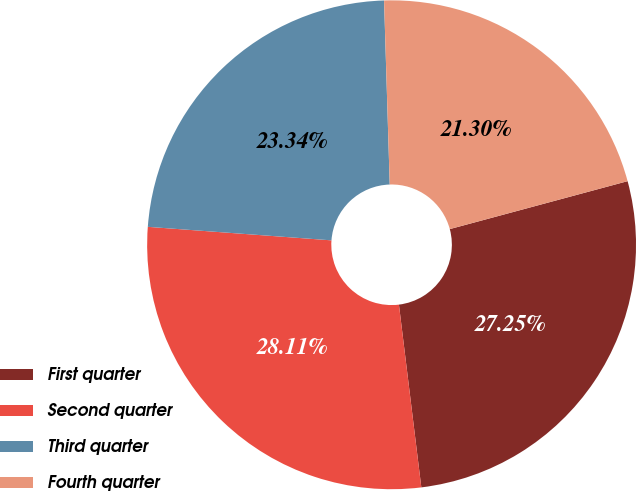Convert chart. <chart><loc_0><loc_0><loc_500><loc_500><pie_chart><fcel>First quarter<fcel>Second quarter<fcel>Third quarter<fcel>Fourth quarter<nl><fcel>27.25%<fcel>28.11%<fcel>23.34%<fcel>21.3%<nl></chart> 